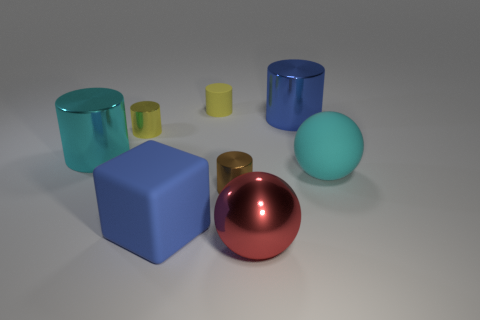Subtract 2 cylinders. How many cylinders are left? 3 Subtract all blue cylinders. How many cylinders are left? 4 Subtract all tiny brown cylinders. How many cylinders are left? 4 Subtract all green cylinders. Subtract all cyan balls. How many cylinders are left? 5 Add 1 tiny brown metallic objects. How many objects exist? 9 Subtract all cubes. How many objects are left? 7 Add 3 small brown shiny cubes. How many small brown shiny cubes exist? 3 Subtract 1 cyan spheres. How many objects are left? 7 Subtract all balls. Subtract all purple matte things. How many objects are left? 6 Add 3 big red objects. How many big red objects are left? 4 